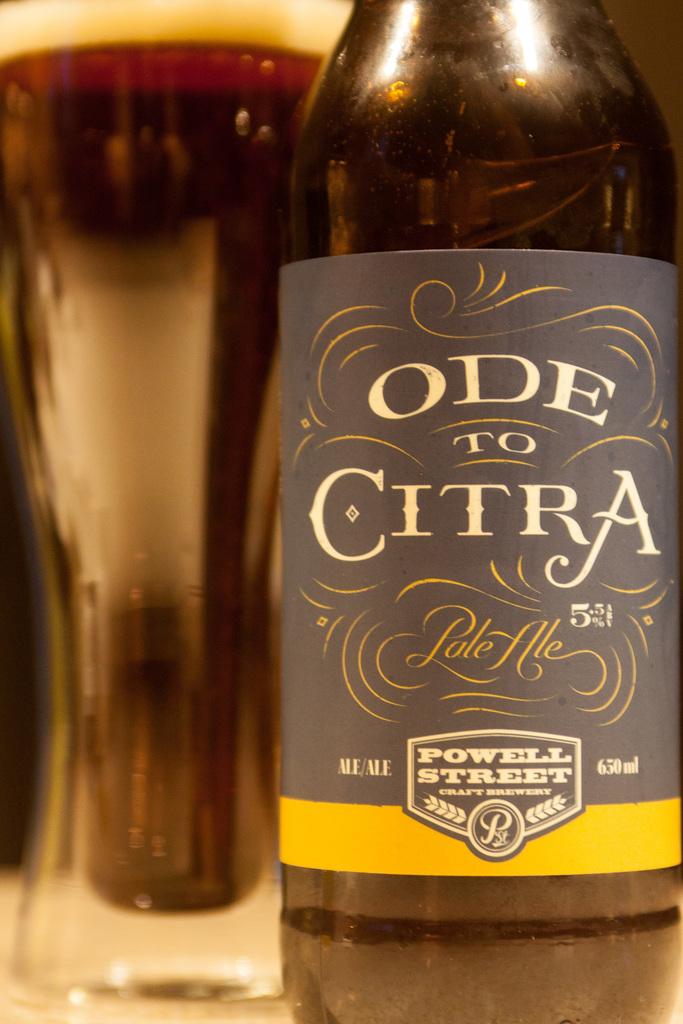What is the beer called?
Provide a succinct answer. Ode to citra. How many ml of pale ale are in the bottle?
Keep it short and to the point. 650. 